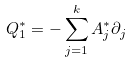<formula> <loc_0><loc_0><loc_500><loc_500>Q _ { 1 } ^ { \ast } = - \sum _ { j = 1 } ^ { k } A _ { j } ^ { \ast } \partial _ { j }</formula> 